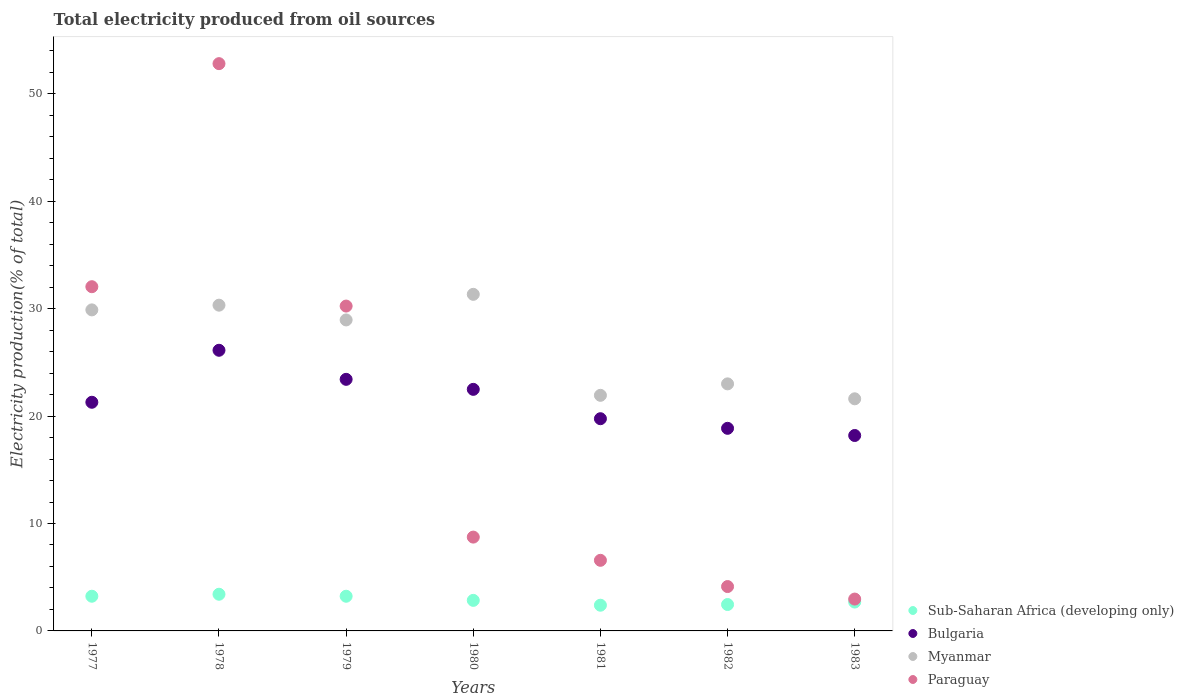How many different coloured dotlines are there?
Offer a terse response. 4. Is the number of dotlines equal to the number of legend labels?
Offer a very short reply. Yes. What is the total electricity produced in Bulgaria in 1980?
Your response must be concise. 22.49. Across all years, what is the maximum total electricity produced in Bulgaria?
Provide a succinct answer. 26.13. Across all years, what is the minimum total electricity produced in Sub-Saharan Africa (developing only)?
Keep it short and to the point. 2.39. In which year was the total electricity produced in Sub-Saharan Africa (developing only) maximum?
Provide a short and direct response. 1978. In which year was the total electricity produced in Bulgaria minimum?
Offer a terse response. 1983. What is the total total electricity produced in Sub-Saharan Africa (developing only) in the graph?
Your response must be concise. 20.26. What is the difference between the total electricity produced in Bulgaria in 1978 and that in 1981?
Offer a very short reply. 6.37. What is the difference between the total electricity produced in Paraguay in 1983 and the total electricity produced in Myanmar in 1977?
Ensure brevity in your answer.  -26.93. What is the average total electricity produced in Sub-Saharan Africa (developing only) per year?
Offer a very short reply. 2.89. In the year 1977, what is the difference between the total electricity produced in Bulgaria and total electricity produced in Myanmar?
Offer a terse response. -8.6. What is the ratio of the total electricity produced in Sub-Saharan Africa (developing only) in 1978 to that in 1981?
Your response must be concise. 1.43. What is the difference between the highest and the second highest total electricity produced in Bulgaria?
Provide a short and direct response. 2.71. What is the difference between the highest and the lowest total electricity produced in Paraguay?
Provide a succinct answer. 49.85. In how many years, is the total electricity produced in Paraguay greater than the average total electricity produced in Paraguay taken over all years?
Provide a succinct answer. 3. Is the sum of the total electricity produced in Sub-Saharan Africa (developing only) in 1978 and 1980 greater than the maximum total electricity produced in Myanmar across all years?
Offer a terse response. No. Is it the case that in every year, the sum of the total electricity produced in Myanmar and total electricity produced in Sub-Saharan Africa (developing only)  is greater than the total electricity produced in Bulgaria?
Give a very brief answer. Yes. Is the total electricity produced in Myanmar strictly greater than the total electricity produced in Paraguay over the years?
Give a very brief answer. No. Is the total electricity produced in Sub-Saharan Africa (developing only) strictly less than the total electricity produced in Myanmar over the years?
Your answer should be compact. Yes. Where does the legend appear in the graph?
Offer a very short reply. Bottom right. How are the legend labels stacked?
Your answer should be very brief. Vertical. What is the title of the graph?
Keep it short and to the point. Total electricity produced from oil sources. Does "Ireland" appear as one of the legend labels in the graph?
Keep it short and to the point. No. What is the label or title of the X-axis?
Ensure brevity in your answer.  Years. What is the Electricity production(% of total) of Sub-Saharan Africa (developing only) in 1977?
Your answer should be compact. 3.23. What is the Electricity production(% of total) of Bulgaria in 1977?
Ensure brevity in your answer.  21.29. What is the Electricity production(% of total) of Myanmar in 1977?
Provide a short and direct response. 29.89. What is the Electricity production(% of total) in Paraguay in 1977?
Your answer should be very brief. 32.05. What is the Electricity production(% of total) in Sub-Saharan Africa (developing only) in 1978?
Your answer should be very brief. 3.41. What is the Electricity production(% of total) in Bulgaria in 1978?
Offer a very short reply. 26.13. What is the Electricity production(% of total) of Myanmar in 1978?
Your answer should be compact. 30.33. What is the Electricity production(% of total) of Paraguay in 1978?
Your answer should be compact. 52.82. What is the Electricity production(% of total) of Sub-Saharan Africa (developing only) in 1979?
Provide a short and direct response. 3.23. What is the Electricity production(% of total) in Bulgaria in 1979?
Provide a succinct answer. 23.42. What is the Electricity production(% of total) in Myanmar in 1979?
Ensure brevity in your answer.  28.96. What is the Electricity production(% of total) of Paraguay in 1979?
Your answer should be compact. 30.25. What is the Electricity production(% of total) in Sub-Saharan Africa (developing only) in 1980?
Provide a succinct answer. 2.84. What is the Electricity production(% of total) of Bulgaria in 1980?
Provide a short and direct response. 22.49. What is the Electricity production(% of total) of Myanmar in 1980?
Your response must be concise. 31.34. What is the Electricity production(% of total) of Paraguay in 1980?
Offer a very short reply. 8.74. What is the Electricity production(% of total) of Sub-Saharan Africa (developing only) in 1981?
Provide a short and direct response. 2.39. What is the Electricity production(% of total) in Bulgaria in 1981?
Provide a short and direct response. 19.76. What is the Electricity production(% of total) of Myanmar in 1981?
Offer a terse response. 21.94. What is the Electricity production(% of total) in Paraguay in 1981?
Keep it short and to the point. 6.57. What is the Electricity production(% of total) of Sub-Saharan Africa (developing only) in 1982?
Your answer should be compact. 2.46. What is the Electricity production(% of total) in Bulgaria in 1982?
Offer a terse response. 18.86. What is the Electricity production(% of total) in Myanmar in 1982?
Make the answer very short. 23. What is the Electricity production(% of total) of Paraguay in 1982?
Offer a very short reply. 4.13. What is the Electricity production(% of total) of Sub-Saharan Africa (developing only) in 1983?
Ensure brevity in your answer.  2.69. What is the Electricity production(% of total) of Bulgaria in 1983?
Offer a very short reply. 18.2. What is the Electricity production(% of total) in Myanmar in 1983?
Give a very brief answer. 21.61. What is the Electricity production(% of total) in Paraguay in 1983?
Give a very brief answer. 2.97. Across all years, what is the maximum Electricity production(% of total) of Sub-Saharan Africa (developing only)?
Ensure brevity in your answer.  3.41. Across all years, what is the maximum Electricity production(% of total) in Bulgaria?
Provide a succinct answer. 26.13. Across all years, what is the maximum Electricity production(% of total) in Myanmar?
Your answer should be very brief. 31.34. Across all years, what is the maximum Electricity production(% of total) of Paraguay?
Give a very brief answer. 52.82. Across all years, what is the minimum Electricity production(% of total) in Sub-Saharan Africa (developing only)?
Your response must be concise. 2.39. Across all years, what is the minimum Electricity production(% of total) of Bulgaria?
Ensure brevity in your answer.  18.2. Across all years, what is the minimum Electricity production(% of total) in Myanmar?
Give a very brief answer. 21.61. Across all years, what is the minimum Electricity production(% of total) of Paraguay?
Keep it short and to the point. 2.97. What is the total Electricity production(% of total) of Sub-Saharan Africa (developing only) in the graph?
Your answer should be compact. 20.26. What is the total Electricity production(% of total) of Bulgaria in the graph?
Give a very brief answer. 150.15. What is the total Electricity production(% of total) in Myanmar in the graph?
Ensure brevity in your answer.  187.06. What is the total Electricity production(% of total) of Paraguay in the graph?
Offer a very short reply. 137.52. What is the difference between the Electricity production(% of total) of Sub-Saharan Africa (developing only) in 1977 and that in 1978?
Offer a very short reply. -0.19. What is the difference between the Electricity production(% of total) of Bulgaria in 1977 and that in 1978?
Keep it short and to the point. -4.84. What is the difference between the Electricity production(% of total) of Myanmar in 1977 and that in 1978?
Keep it short and to the point. -0.44. What is the difference between the Electricity production(% of total) in Paraguay in 1977 and that in 1978?
Provide a succinct answer. -20.77. What is the difference between the Electricity production(% of total) in Sub-Saharan Africa (developing only) in 1977 and that in 1979?
Provide a short and direct response. 0. What is the difference between the Electricity production(% of total) in Bulgaria in 1977 and that in 1979?
Make the answer very short. -2.14. What is the difference between the Electricity production(% of total) of Myanmar in 1977 and that in 1979?
Make the answer very short. 0.94. What is the difference between the Electricity production(% of total) in Paraguay in 1977 and that in 1979?
Make the answer very short. 1.8. What is the difference between the Electricity production(% of total) in Sub-Saharan Africa (developing only) in 1977 and that in 1980?
Offer a very short reply. 0.39. What is the difference between the Electricity production(% of total) of Bulgaria in 1977 and that in 1980?
Give a very brief answer. -1.2. What is the difference between the Electricity production(% of total) of Myanmar in 1977 and that in 1980?
Provide a short and direct response. -1.45. What is the difference between the Electricity production(% of total) in Paraguay in 1977 and that in 1980?
Offer a terse response. 23.31. What is the difference between the Electricity production(% of total) of Sub-Saharan Africa (developing only) in 1977 and that in 1981?
Provide a succinct answer. 0.84. What is the difference between the Electricity production(% of total) of Bulgaria in 1977 and that in 1981?
Ensure brevity in your answer.  1.53. What is the difference between the Electricity production(% of total) of Myanmar in 1977 and that in 1981?
Make the answer very short. 7.96. What is the difference between the Electricity production(% of total) in Paraguay in 1977 and that in 1981?
Make the answer very short. 25.48. What is the difference between the Electricity production(% of total) of Sub-Saharan Africa (developing only) in 1977 and that in 1982?
Provide a short and direct response. 0.77. What is the difference between the Electricity production(% of total) in Bulgaria in 1977 and that in 1982?
Your answer should be compact. 2.43. What is the difference between the Electricity production(% of total) in Myanmar in 1977 and that in 1982?
Offer a terse response. 6.89. What is the difference between the Electricity production(% of total) in Paraguay in 1977 and that in 1982?
Your answer should be very brief. 27.92. What is the difference between the Electricity production(% of total) in Sub-Saharan Africa (developing only) in 1977 and that in 1983?
Your answer should be very brief. 0.54. What is the difference between the Electricity production(% of total) in Bulgaria in 1977 and that in 1983?
Provide a succinct answer. 3.09. What is the difference between the Electricity production(% of total) of Myanmar in 1977 and that in 1983?
Offer a terse response. 8.28. What is the difference between the Electricity production(% of total) of Paraguay in 1977 and that in 1983?
Your response must be concise. 29.08. What is the difference between the Electricity production(% of total) in Sub-Saharan Africa (developing only) in 1978 and that in 1979?
Your answer should be compact. 0.19. What is the difference between the Electricity production(% of total) in Bulgaria in 1978 and that in 1979?
Your response must be concise. 2.71. What is the difference between the Electricity production(% of total) of Myanmar in 1978 and that in 1979?
Give a very brief answer. 1.37. What is the difference between the Electricity production(% of total) of Paraguay in 1978 and that in 1979?
Your answer should be very brief. 22.57. What is the difference between the Electricity production(% of total) in Sub-Saharan Africa (developing only) in 1978 and that in 1980?
Give a very brief answer. 0.57. What is the difference between the Electricity production(% of total) of Bulgaria in 1978 and that in 1980?
Offer a very short reply. 3.64. What is the difference between the Electricity production(% of total) in Myanmar in 1978 and that in 1980?
Offer a terse response. -1.01. What is the difference between the Electricity production(% of total) of Paraguay in 1978 and that in 1980?
Offer a terse response. 44.08. What is the difference between the Electricity production(% of total) in Sub-Saharan Africa (developing only) in 1978 and that in 1981?
Your response must be concise. 1.02. What is the difference between the Electricity production(% of total) in Bulgaria in 1978 and that in 1981?
Keep it short and to the point. 6.37. What is the difference between the Electricity production(% of total) in Myanmar in 1978 and that in 1981?
Your answer should be compact. 8.39. What is the difference between the Electricity production(% of total) in Paraguay in 1978 and that in 1981?
Offer a terse response. 46.24. What is the difference between the Electricity production(% of total) of Sub-Saharan Africa (developing only) in 1978 and that in 1982?
Offer a very short reply. 0.96. What is the difference between the Electricity production(% of total) of Bulgaria in 1978 and that in 1982?
Your answer should be compact. 7.27. What is the difference between the Electricity production(% of total) of Myanmar in 1978 and that in 1982?
Your response must be concise. 7.33. What is the difference between the Electricity production(% of total) in Paraguay in 1978 and that in 1982?
Make the answer very short. 48.69. What is the difference between the Electricity production(% of total) in Sub-Saharan Africa (developing only) in 1978 and that in 1983?
Make the answer very short. 0.73. What is the difference between the Electricity production(% of total) of Bulgaria in 1978 and that in 1983?
Offer a terse response. 7.93. What is the difference between the Electricity production(% of total) in Myanmar in 1978 and that in 1983?
Offer a terse response. 8.72. What is the difference between the Electricity production(% of total) of Paraguay in 1978 and that in 1983?
Your answer should be very brief. 49.85. What is the difference between the Electricity production(% of total) in Sub-Saharan Africa (developing only) in 1979 and that in 1980?
Keep it short and to the point. 0.38. What is the difference between the Electricity production(% of total) in Bulgaria in 1979 and that in 1980?
Make the answer very short. 0.93. What is the difference between the Electricity production(% of total) of Myanmar in 1979 and that in 1980?
Offer a very short reply. -2.38. What is the difference between the Electricity production(% of total) in Paraguay in 1979 and that in 1980?
Your answer should be compact. 21.51. What is the difference between the Electricity production(% of total) of Sub-Saharan Africa (developing only) in 1979 and that in 1981?
Make the answer very short. 0.84. What is the difference between the Electricity production(% of total) in Bulgaria in 1979 and that in 1981?
Provide a short and direct response. 3.67. What is the difference between the Electricity production(% of total) of Myanmar in 1979 and that in 1981?
Offer a terse response. 7.02. What is the difference between the Electricity production(% of total) of Paraguay in 1979 and that in 1981?
Ensure brevity in your answer.  23.67. What is the difference between the Electricity production(% of total) of Sub-Saharan Africa (developing only) in 1979 and that in 1982?
Keep it short and to the point. 0.77. What is the difference between the Electricity production(% of total) of Bulgaria in 1979 and that in 1982?
Offer a terse response. 4.56. What is the difference between the Electricity production(% of total) of Myanmar in 1979 and that in 1982?
Ensure brevity in your answer.  5.95. What is the difference between the Electricity production(% of total) in Paraguay in 1979 and that in 1982?
Your answer should be very brief. 26.11. What is the difference between the Electricity production(% of total) of Sub-Saharan Africa (developing only) in 1979 and that in 1983?
Offer a terse response. 0.54. What is the difference between the Electricity production(% of total) in Bulgaria in 1979 and that in 1983?
Give a very brief answer. 5.23. What is the difference between the Electricity production(% of total) in Myanmar in 1979 and that in 1983?
Your response must be concise. 7.34. What is the difference between the Electricity production(% of total) of Paraguay in 1979 and that in 1983?
Provide a short and direct response. 27.28. What is the difference between the Electricity production(% of total) in Sub-Saharan Africa (developing only) in 1980 and that in 1981?
Keep it short and to the point. 0.45. What is the difference between the Electricity production(% of total) of Bulgaria in 1980 and that in 1981?
Make the answer very short. 2.73. What is the difference between the Electricity production(% of total) of Myanmar in 1980 and that in 1981?
Your answer should be very brief. 9.4. What is the difference between the Electricity production(% of total) in Paraguay in 1980 and that in 1981?
Offer a terse response. 2.16. What is the difference between the Electricity production(% of total) of Sub-Saharan Africa (developing only) in 1980 and that in 1982?
Provide a short and direct response. 0.39. What is the difference between the Electricity production(% of total) in Bulgaria in 1980 and that in 1982?
Keep it short and to the point. 3.63. What is the difference between the Electricity production(% of total) in Myanmar in 1980 and that in 1982?
Provide a succinct answer. 8.34. What is the difference between the Electricity production(% of total) in Paraguay in 1980 and that in 1982?
Provide a succinct answer. 4.6. What is the difference between the Electricity production(% of total) in Sub-Saharan Africa (developing only) in 1980 and that in 1983?
Give a very brief answer. 0.16. What is the difference between the Electricity production(% of total) in Bulgaria in 1980 and that in 1983?
Offer a very short reply. 4.3. What is the difference between the Electricity production(% of total) in Myanmar in 1980 and that in 1983?
Offer a very short reply. 9.73. What is the difference between the Electricity production(% of total) of Paraguay in 1980 and that in 1983?
Make the answer very short. 5.77. What is the difference between the Electricity production(% of total) of Sub-Saharan Africa (developing only) in 1981 and that in 1982?
Your answer should be very brief. -0.06. What is the difference between the Electricity production(% of total) of Bulgaria in 1981 and that in 1982?
Offer a very short reply. 0.89. What is the difference between the Electricity production(% of total) in Myanmar in 1981 and that in 1982?
Keep it short and to the point. -1.07. What is the difference between the Electricity production(% of total) of Paraguay in 1981 and that in 1982?
Give a very brief answer. 2.44. What is the difference between the Electricity production(% of total) of Sub-Saharan Africa (developing only) in 1981 and that in 1983?
Offer a very short reply. -0.29. What is the difference between the Electricity production(% of total) of Bulgaria in 1981 and that in 1983?
Keep it short and to the point. 1.56. What is the difference between the Electricity production(% of total) of Myanmar in 1981 and that in 1983?
Your response must be concise. 0.32. What is the difference between the Electricity production(% of total) of Paraguay in 1981 and that in 1983?
Your response must be concise. 3.61. What is the difference between the Electricity production(% of total) in Sub-Saharan Africa (developing only) in 1982 and that in 1983?
Provide a short and direct response. -0.23. What is the difference between the Electricity production(% of total) in Bulgaria in 1982 and that in 1983?
Provide a succinct answer. 0.67. What is the difference between the Electricity production(% of total) of Myanmar in 1982 and that in 1983?
Ensure brevity in your answer.  1.39. What is the difference between the Electricity production(% of total) of Paraguay in 1982 and that in 1983?
Provide a short and direct response. 1.17. What is the difference between the Electricity production(% of total) in Sub-Saharan Africa (developing only) in 1977 and the Electricity production(% of total) in Bulgaria in 1978?
Your answer should be very brief. -22.9. What is the difference between the Electricity production(% of total) in Sub-Saharan Africa (developing only) in 1977 and the Electricity production(% of total) in Myanmar in 1978?
Provide a succinct answer. -27.1. What is the difference between the Electricity production(% of total) in Sub-Saharan Africa (developing only) in 1977 and the Electricity production(% of total) in Paraguay in 1978?
Provide a short and direct response. -49.59. What is the difference between the Electricity production(% of total) in Bulgaria in 1977 and the Electricity production(% of total) in Myanmar in 1978?
Your answer should be compact. -9.04. What is the difference between the Electricity production(% of total) in Bulgaria in 1977 and the Electricity production(% of total) in Paraguay in 1978?
Give a very brief answer. -31.53. What is the difference between the Electricity production(% of total) in Myanmar in 1977 and the Electricity production(% of total) in Paraguay in 1978?
Your response must be concise. -22.93. What is the difference between the Electricity production(% of total) in Sub-Saharan Africa (developing only) in 1977 and the Electricity production(% of total) in Bulgaria in 1979?
Make the answer very short. -20.19. What is the difference between the Electricity production(% of total) in Sub-Saharan Africa (developing only) in 1977 and the Electricity production(% of total) in Myanmar in 1979?
Give a very brief answer. -25.73. What is the difference between the Electricity production(% of total) of Sub-Saharan Africa (developing only) in 1977 and the Electricity production(% of total) of Paraguay in 1979?
Your response must be concise. -27.02. What is the difference between the Electricity production(% of total) in Bulgaria in 1977 and the Electricity production(% of total) in Myanmar in 1979?
Provide a short and direct response. -7.67. What is the difference between the Electricity production(% of total) in Bulgaria in 1977 and the Electricity production(% of total) in Paraguay in 1979?
Provide a short and direct response. -8.96. What is the difference between the Electricity production(% of total) of Myanmar in 1977 and the Electricity production(% of total) of Paraguay in 1979?
Your response must be concise. -0.36. What is the difference between the Electricity production(% of total) in Sub-Saharan Africa (developing only) in 1977 and the Electricity production(% of total) in Bulgaria in 1980?
Provide a short and direct response. -19.26. What is the difference between the Electricity production(% of total) of Sub-Saharan Africa (developing only) in 1977 and the Electricity production(% of total) of Myanmar in 1980?
Give a very brief answer. -28.11. What is the difference between the Electricity production(% of total) in Sub-Saharan Africa (developing only) in 1977 and the Electricity production(% of total) in Paraguay in 1980?
Provide a succinct answer. -5.51. What is the difference between the Electricity production(% of total) of Bulgaria in 1977 and the Electricity production(% of total) of Myanmar in 1980?
Your answer should be compact. -10.05. What is the difference between the Electricity production(% of total) of Bulgaria in 1977 and the Electricity production(% of total) of Paraguay in 1980?
Offer a terse response. 12.55. What is the difference between the Electricity production(% of total) in Myanmar in 1977 and the Electricity production(% of total) in Paraguay in 1980?
Ensure brevity in your answer.  21.16. What is the difference between the Electricity production(% of total) in Sub-Saharan Africa (developing only) in 1977 and the Electricity production(% of total) in Bulgaria in 1981?
Give a very brief answer. -16.53. What is the difference between the Electricity production(% of total) in Sub-Saharan Africa (developing only) in 1977 and the Electricity production(% of total) in Myanmar in 1981?
Make the answer very short. -18.71. What is the difference between the Electricity production(% of total) of Sub-Saharan Africa (developing only) in 1977 and the Electricity production(% of total) of Paraguay in 1981?
Offer a very short reply. -3.34. What is the difference between the Electricity production(% of total) in Bulgaria in 1977 and the Electricity production(% of total) in Myanmar in 1981?
Make the answer very short. -0.65. What is the difference between the Electricity production(% of total) of Bulgaria in 1977 and the Electricity production(% of total) of Paraguay in 1981?
Give a very brief answer. 14.72. What is the difference between the Electricity production(% of total) of Myanmar in 1977 and the Electricity production(% of total) of Paraguay in 1981?
Keep it short and to the point. 23.32. What is the difference between the Electricity production(% of total) of Sub-Saharan Africa (developing only) in 1977 and the Electricity production(% of total) of Bulgaria in 1982?
Provide a short and direct response. -15.63. What is the difference between the Electricity production(% of total) of Sub-Saharan Africa (developing only) in 1977 and the Electricity production(% of total) of Myanmar in 1982?
Offer a terse response. -19.77. What is the difference between the Electricity production(% of total) in Sub-Saharan Africa (developing only) in 1977 and the Electricity production(% of total) in Paraguay in 1982?
Make the answer very short. -0.9. What is the difference between the Electricity production(% of total) of Bulgaria in 1977 and the Electricity production(% of total) of Myanmar in 1982?
Your answer should be compact. -1.71. What is the difference between the Electricity production(% of total) in Bulgaria in 1977 and the Electricity production(% of total) in Paraguay in 1982?
Ensure brevity in your answer.  17.16. What is the difference between the Electricity production(% of total) in Myanmar in 1977 and the Electricity production(% of total) in Paraguay in 1982?
Your answer should be compact. 25.76. What is the difference between the Electricity production(% of total) of Sub-Saharan Africa (developing only) in 1977 and the Electricity production(% of total) of Bulgaria in 1983?
Offer a very short reply. -14.97. What is the difference between the Electricity production(% of total) in Sub-Saharan Africa (developing only) in 1977 and the Electricity production(% of total) in Myanmar in 1983?
Provide a short and direct response. -18.38. What is the difference between the Electricity production(% of total) in Sub-Saharan Africa (developing only) in 1977 and the Electricity production(% of total) in Paraguay in 1983?
Your response must be concise. 0.26. What is the difference between the Electricity production(% of total) in Bulgaria in 1977 and the Electricity production(% of total) in Myanmar in 1983?
Offer a terse response. -0.32. What is the difference between the Electricity production(% of total) in Bulgaria in 1977 and the Electricity production(% of total) in Paraguay in 1983?
Keep it short and to the point. 18.32. What is the difference between the Electricity production(% of total) of Myanmar in 1977 and the Electricity production(% of total) of Paraguay in 1983?
Offer a terse response. 26.93. What is the difference between the Electricity production(% of total) of Sub-Saharan Africa (developing only) in 1978 and the Electricity production(% of total) of Bulgaria in 1979?
Provide a succinct answer. -20.01. What is the difference between the Electricity production(% of total) of Sub-Saharan Africa (developing only) in 1978 and the Electricity production(% of total) of Myanmar in 1979?
Make the answer very short. -25.54. What is the difference between the Electricity production(% of total) of Sub-Saharan Africa (developing only) in 1978 and the Electricity production(% of total) of Paraguay in 1979?
Keep it short and to the point. -26.83. What is the difference between the Electricity production(% of total) of Bulgaria in 1978 and the Electricity production(% of total) of Myanmar in 1979?
Give a very brief answer. -2.82. What is the difference between the Electricity production(% of total) of Bulgaria in 1978 and the Electricity production(% of total) of Paraguay in 1979?
Provide a short and direct response. -4.12. What is the difference between the Electricity production(% of total) in Myanmar in 1978 and the Electricity production(% of total) in Paraguay in 1979?
Make the answer very short. 0.08. What is the difference between the Electricity production(% of total) of Sub-Saharan Africa (developing only) in 1978 and the Electricity production(% of total) of Bulgaria in 1980?
Offer a terse response. -19.08. What is the difference between the Electricity production(% of total) of Sub-Saharan Africa (developing only) in 1978 and the Electricity production(% of total) of Myanmar in 1980?
Provide a succinct answer. -27.92. What is the difference between the Electricity production(% of total) of Sub-Saharan Africa (developing only) in 1978 and the Electricity production(% of total) of Paraguay in 1980?
Provide a succinct answer. -5.32. What is the difference between the Electricity production(% of total) in Bulgaria in 1978 and the Electricity production(% of total) in Myanmar in 1980?
Ensure brevity in your answer.  -5.21. What is the difference between the Electricity production(% of total) in Bulgaria in 1978 and the Electricity production(% of total) in Paraguay in 1980?
Make the answer very short. 17.4. What is the difference between the Electricity production(% of total) in Myanmar in 1978 and the Electricity production(% of total) in Paraguay in 1980?
Keep it short and to the point. 21.59. What is the difference between the Electricity production(% of total) in Sub-Saharan Africa (developing only) in 1978 and the Electricity production(% of total) in Bulgaria in 1981?
Keep it short and to the point. -16.34. What is the difference between the Electricity production(% of total) in Sub-Saharan Africa (developing only) in 1978 and the Electricity production(% of total) in Myanmar in 1981?
Your response must be concise. -18.52. What is the difference between the Electricity production(% of total) in Sub-Saharan Africa (developing only) in 1978 and the Electricity production(% of total) in Paraguay in 1981?
Keep it short and to the point. -3.16. What is the difference between the Electricity production(% of total) of Bulgaria in 1978 and the Electricity production(% of total) of Myanmar in 1981?
Give a very brief answer. 4.2. What is the difference between the Electricity production(% of total) of Bulgaria in 1978 and the Electricity production(% of total) of Paraguay in 1981?
Keep it short and to the point. 19.56. What is the difference between the Electricity production(% of total) of Myanmar in 1978 and the Electricity production(% of total) of Paraguay in 1981?
Ensure brevity in your answer.  23.76. What is the difference between the Electricity production(% of total) in Sub-Saharan Africa (developing only) in 1978 and the Electricity production(% of total) in Bulgaria in 1982?
Your response must be concise. -15.45. What is the difference between the Electricity production(% of total) in Sub-Saharan Africa (developing only) in 1978 and the Electricity production(% of total) in Myanmar in 1982?
Offer a very short reply. -19.59. What is the difference between the Electricity production(% of total) of Sub-Saharan Africa (developing only) in 1978 and the Electricity production(% of total) of Paraguay in 1982?
Offer a very short reply. -0.72. What is the difference between the Electricity production(% of total) of Bulgaria in 1978 and the Electricity production(% of total) of Myanmar in 1982?
Give a very brief answer. 3.13. What is the difference between the Electricity production(% of total) of Bulgaria in 1978 and the Electricity production(% of total) of Paraguay in 1982?
Offer a very short reply. 22. What is the difference between the Electricity production(% of total) of Myanmar in 1978 and the Electricity production(% of total) of Paraguay in 1982?
Make the answer very short. 26.2. What is the difference between the Electricity production(% of total) of Sub-Saharan Africa (developing only) in 1978 and the Electricity production(% of total) of Bulgaria in 1983?
Provide a succinct answer. -14.78. What is the difference between the Electricity production(% of total) of Sub-Saharan Africa (developing only) in 1978 and the Electricity production(% of total) of Myanmar in 1983?
Ensure brevity in your answer.  -18.2. What is the difference between the Electricity production(% of total) in Sub-Saharan Africa (developing only) in 1978 and the Electricity production(% of total) in Paraguay in 1983?
Keep it short and to the point. 0.45. What is the difference between the Electricity production(% of total) in Bulgaria in 1978 and the Electricity production(% of total) in Myanmar in 1983?
Offer a very short reply. 4.52. What is the difference between the Electricity production(% of total) in Bulgaria in 1978 and the Electricity production(% of total) in Paraguay in 1983?
Give a very brief answer. 23.16. What is the difference between the Electricity production(% of total) of Myanmar in 1978 and the Electricity production(% of total) of Paraguay in 1983?
Provide a short and direct response. 27.36. What is the difference between the Electricity production(% of total) of Sub-Saharan Africa (developing only) in 1979 and the Electricity production(% of total) of Bulgaria in 1980?
Provide a succinct answer. -19.26. What is the difference between the Electricity production(% of total) in Sub-Saharan Africa (developing only) in 1979 and the Electricity production(% of total) in Myanmar in 1980?
Give a very brief answer. -28.11. What is the difference between the Electricity production(% of total) of Sub-Saharan Africa (developing only) in 1979 and the Electricity production(% of total) of Paraguay in 1980?
Offer a terse response. -5.51. What is the difference between the Electricity production(% of total) of Bulgaria in 1979 and the Electricity production(% of total) of Myanmar in 1980?
Offer a very short reply. -7.91. What is the difference between the Electricity production(% of total) in Bulgaria in 1979 and the Electricity production(% of total) in Paraguay in 1980?
Ensure brevity in your answer.  14.69. What is the difference between the Electricity production(% of total) of Myanmar in 1979 and the Electricity production(% of total) of Paraguay in 1980?
Offer a very short reply. 20.22. What is the difference between the Electricity production(% of total) in Sub-Saharan Africa (developing only) in 1979 and the Electricity production(% of total) in Bulgaria in 1981?
Make the answer very short. -16.53. What is the difference between the Electricity production(% of total) of Sub-Saharan Africa (developing only) in 1979 and the Electricity production(% of total) of Myanmar in 1981?
Make the answer very short. -18.71. What is the difference between the Electricity production(% of total) of Sub-Saharan Africa (developing only) in 1979 and the Electricity production(% of total) of Paraguay in 1981?
Your answer should be very brief. -3.34. What is the difference between the Electricity production(% of total) in Bulgaria in 1979 and the Electricity production(% of total) in Myanmar in 1981?
Ensure brevity in your answer.  1.49. What is the difference between the Electricity production(% of total) in Bulgaria in 1979 and the Electricity production(% of total) in Paraguay in 1981?
Your answer should be compact. 16.85. What is the difference between the Electricity production(% of total) of Myanmar in 1979 and the Electricity production(% of total) of Paraguay in 1981?
Keep it short and to the point. 22.38. What is the difference between the Electricity production(% of total) in Sub-Saharan Africa (developing only) in 1979 and the Electricity production(% of total) in Bulgaria in 1982?
Offer a very short reply. -15.63. What is the difference between the Electricity production(% of total) of Sub-Saharan Africa (developing only) in 1979 and the Electricity production(% of total) of Myanmar in 1982?
Provide a succinct answer. -19.77. What is the difference between the Electricity production(% of total) in Sub-Saharan Africa (developing only) in 1979 and the Electricity production(% of total) in Paraguay in 1982?
Provide a short and direct response. -0.9. What is the difference between the Electricity production(% of total) in Bulgaria in 1979 and the Electricity production(% of total) in Myanmar in 1982?
Give a very brief answer. 0.42. What is the difference between the Electricity production(% of total) in Bulgaria in 1979 and the Electricity production(% of total) in Paraguay in 1982?
Your answer should be very brief. 19.29. What is the difference between the Electricity production(% of total) of Myanmar in 1979 and the Electricity production(% of total) of Paraguay in 1982?
Offer a very short reply. 24.82. What is the difference between the Electricity production(% of total) of Sub-Saharan Africa (developing only) in 1979 and the Electricity production(% of total) of Bulgaria in 1983?
Ensure brevity in your answer.  -14.97. What is the difference between the Electricity production(% of total) in Sub-Saharan Africa (developing only) in 1979 and the Electricity production(% of total) in Myanmar in 1983?
Ensure brevity in your answer.  -18.38. What is the difference between the Electricity production(% of total) in Sub-Saharan Africa (developing only) in 1979 and the Electricity production(% of total) in Paraguay in 1983?
Keep it short and to the point. 0.26. What is the difference between the Electricity production(% of total) of Bulgaria in 1979 and the Electricity production(% of total) of Myanmar in 1983?
Keep it short and to the point. 1.81. What is the difference between the Electricity production(% of total) in Bulgaria in 1979 and the Electricity production(% of total) in Paraguay in 1983?
Ensure brevity in your answer.  20.46. What is the difference between the Electricity production(% of total) in Myanmar in 1979 and the Electricity production(% of total) in Paraguay in 1983?
Offer a terse response. 25.99. What is the difference between the Electricity production(% of total) of Sub-Saharan Africa (developing only) in 1980 and the Electricity production(% of total) of Bulgaria in 1981?
Keep it short and to the point. -16.91. What is the difference between the Electricity production(% of total) of Sub-Saharan Africa (developing only) in 1980 and the Electricity production(% of total) of Myanmar in 1981?
Your answer should be very brief. -19.09. What is the difference between the Electricity production(% of total) in Sub-Saharan Africa (developing only) in 1980 and the Electricity production(% of total) in Paraguay in 1981?
Give a very brief answer. -3.73. What is the difference between the Electricity production(% of total) in Bulgaria in 1980 and the Electricity production(% of total) in Myanmar in 1981?
Offer a terse response. 0.56. What is the difference between the Electricity production(% of total) in Bulgaria in 1980 and the Electricity production(% of total) in Paraguay in 1981?
Your answer should be compact. 15.92. What is the difference between the Electricity production(% of total) of Myanmar in 1980 and the Electricity production(% of total) of Paraguay in 1981?
Provide a short and direct response. 24.76. What is the difference between the Electricity production(% of total) in Sub-Saharan Africa (developing only) in 1980 and the Electricity production(% of total) in Bulgaria in 1982?
Provide a short and direct response. -16.02. What is the difference between the Electricity production(% of total) in Sub-Saharan Africa (developing only) in 1980 and the Electricity production(% of total) in Myanmar in 1982?
Provide a short and direct response. -20.16. What is the difference between the Electricity production(% of total) in Sub-Saharan Africa (developing only) in 1980 and the Electricity production(% of total) in Paraguay in 1982?
Your response must be concise. -1.29. What is the difference between the Electricity production(% of total) of Bulgaria in 1980 and the Electricity production(% of total) of Myanmar in 1982?
Give a very brief answer. -0.51. What is the difference between the Electricity production(% of total) of Bulgaria in 1980 and the Electricity production(% of total) of Paraguay in 1982?
Provide a short and direct response. 18.36. What is the difference between the Electricity production(% of total) in Myanmar in 1980 and the Electricity production(% of total) in Paraguay in 1982?
Your answer should be very brief. 27.21. What is the difference between the Electricity production(% of total) of Sub-Saharan Africa (developing only) in 1980 and the Electricity production(% of total) of Bulgaria in 1983?
Make the answer very short. -15.35. What is the difference between the Electricity production(% of total) in Sub-Saharan Africa (developing only) in 1980 and the Electricity production(% of total) in Myanmar in 1983?
Provide a succinct answer. -18.77. What is the difference between the Electricity production(% of total) of Sub-Saharan Africa (developing only) in 1980 and the Electricity production(% of total) of Paraguay in 1983?
Your answer should be very brief. -0.12. What is the difference between the Electricity production(% of total) in Bulgaria in 1980 and the Electricity production(% of total) in Myanmar in 1983?
Keep it short and to the point. 0.88. What is the difference between the Electricity production(% of total) in Bulgaria in 1980 and the Electricity production(% of total) in Paraguay in 1983?
Ensure brevity in your answer.  19.53. What is the difference between the Electricity production(% of total) of Myanmar in 1980 and the Electricity production(% of total) of Paraguay in 1983?
Your response must be concise. 28.37. What is the difference between the Electricity production(% of total) of Sub-Saharan Africa (developing only) in 1981 and the Electricity production(% of total) of Bulgaria in 1982?
Offer a terse response. -16.47. What is the difference between the Electricity production(% of total) of Sub-Saharan Africa (developing only) in 1981 and the Electricity production(% of total) of Myanmar in 1982?
Offer a terse response. -20.61. What is the difference between the Electricity production(% of total) of Sub-Saharan Africa (developing only) in 1981 and the Electricity production(% of total) of Paraguay in 1982?
Ensure brevity in your answer.  -1.74. What is the difference between the Electricity production(% of total) of Bulgaria in 1981 and the Electricity production(% of total) of Myanmar in 1982?
Keep it short and to the point. -3.24. What is the difference between the Electricity production(% of total) of Bulgaria in 1981 and the Electricity production(% of total) of Paraguay in 1982?
Provide a succinct answer. 15.63. What is the difference between the Electricity production(% of total) in Myanmar in 1981 and the Electricity production(% of total) in Paraguay in 1982?
Provide a short and direct response. 17.8. What is the difference between the Electricity production(% of total) of Sub-Saharan Africa (developing only) in 1981 and the Electricity production(% of total) of Bulgaria in 1983?
Your answer should be very brief. -15.8. What is the difference between the Electricity production(% of total) in Sub-Saharan Africa (developing only) in 1981 and the Electricity production(% of total) in Myanmar in 1983?
Make the answer very short. -19.22. What is the difference between the Electricity production(% of total) of Sub-Saharan Africa (developing only) in 1981 and the Electricity production(% of total) of Paraguay in 1983?
Your answer should be very brief. -0.57. What is the difference between the Electricity production(% of total) of Bulgaria in 1981 and the Electricity production(% of total) of Myanmar in 1983?
Your response must be concise. -1.85. What is the difference between the Electricity production(% of total) in Bulgaria in 1981 and the Electricity production(% of total) in Paraguay in 1983?
Ensure brevity in your answer.  16.79. What is the difference between the Electricity production(% of total) of Myanmar in 1981 and the Electricity production(% of total) of Paraguay in 1983?
Keep it short and to the point. 18.97. What is the difference between the Electricity production(% of total) in Sub-Saharan Africa (developing only) in 1982 and the Electricity production(% of total) in Bulgaria in 1983?
Provide a short and direct response. -15.74. What is the difference between the Electricity production(% of total) in Sub-Saharan Africa (developing only) in 1982 and the Electricity production(% of total) in Myanmar in 1983?
Provide a succinct answer. -19.15. What is the difference between the Electricity production(% of total) of Sub-Saharan Africa (developing only) in 1982 and the Electricity production(% of total) of Paraguay in 1983?
Ensure brevity in your answer.  -0.51. What is the difference between the Electricity production(% of total) in Bulgaria in 1982 and the Electricity production(% of total) in Myanmar in 1983?
Your response must be concise. -2.75. What is the difference between the Electricity production(% of total) of Bulgaria in 1982 and the Electricity production(% of total) of Paraguay in 1983?
Offer a terse response. 15.9. What is the difference between the Electricity production(% of total) in Myanmar in 1982 and the Electricity production(% of total) in Paraguay in 1983?
Provide a succinct answer. 20.04. What is the average Electricity production(% of total) of Sub-Saharan Africa (developing only) per year?
Keep it short and to the point. 2.89. What is the average Electricity production(% of total) of Bulgaria per year?
Give a very brief answer. 21.45. What is the average Electricity production(% of total) of Myanmar per year?
Keep it short and to the point. 26.72. What is the average Electricity production(% of total) of Paraguay per year?
Offer a terse response. 19.65. In the year 1977, what is the difference between the Electricity production(% of total) of Sub-Saharan Africa (developing only) and Electricity production(% of total) of Bulgaria?
Your answer should be very brief. -18.06. In the year 1977, what is the difference between the Electricity production(% of total) in Sub-Saharan Africa (developing only) and Electricity production(% of total) in Myanmar?
Your response must be concise. -26.66. In the year 1977, what is the difference between the Electricity production(% of total) of Sub-Saharan Africa (developing only) and Electricity production(% of total) of Paraguay?
Keep it short and to the point. -28.82. In the year 1977, what is the difference between the Electricity production(% of total) of Bulgaria and Electricity production(% of total) of Myanmar?
Keep it short and to the point. -8.6. In the year 1977, what is the difference between the Electricity production(% of total) in Bulgaria and Electricity production(% of total) in Paraguay?
Your answer should be very brief. -10.76. In the year 1977, what is the difference between the Electricity production(% of total) in Myanmar and Electricity production(% of total) in Paraguay?
Make the answer very short. -2.16. In the year 1978, what is the difference between the Electricity production(% of total) of Sub-Saharan Africa (developing only) and Electricity production(% of total) of Bulgaria?
Make the answer very short. -22.72. In the year 1978, what is the difference between the Electricity production(% of total) of Sub-Saharan Africa (developing only) and Electricity production(% of total) of Myanmar?
Your answer should be compact. -26.92. In the year 1978, what is the difference between the Electricity production(% of total) in Sub-Saharan Africa (developing only) and Electricity production(% of total) in Paraguay?
Your response must be concise. -49.4. In the year 1978, what is the difference between the Electricity production(% of total) in Bulgaria and Electricity production(% of total) in Myanmar?
Offer a very short reply. -4.2. In the year 1978, what is the difference between the Electricity production(% of total) of Bulgaria and Electricity production(% of total) of Paraguay?
Keep it short and to the point. -26.69. In the year 1978, what is the difference between the Electricity production(% of total) of Myanmar and Electricity production(% of total) of Paraguay?
Provide a succinct answer. -22.49. In the year 1979, what is the difference between the Electricity production(% of total) in Sub-Saharan Africa (developing only) and Electricity production(% of total) in Bulgaria?
Give a very brief answer. -20.2. In the year 1979, what is the difference between the Electricity production(% of total) of Sub-Saharan Africa (developing only) and Electricity production(% of total) of Myanmar?
Offer a terse response. -25.73. In the year 1979, what is the difference between the Electricity production(% of total) of Sub-Saharan Africa (developing only) and Electricity production(% of total) of Paraguay?
Offer a terse response. -27.02. In the year 1979, what is the difference between the Electricity production(% of total) of Bulgaria and Electricity production(% of total) of Myanmar?
Ensure brevity in your answer.  -5.53. In the year 1979, what is the difference between the Electricity production(% of total) in Bulgaria and Electricity production(% of total) in Paraguay?
Give a very brief answer. -6.82. In the year 1979, what is the difference between the Electricity production(% of total) in Myanmar and Electricity production(% of total) in Paraguay?
Your answer should be very brief. -1.29. In the year 1980, what is the difference between the Electricity production(% of total) in Sub-Saharan Africa (developing only) and Electricity production(% of total) in Bulgaria?
Your answer should be very brief. -19.65. In the year 1980, what is the difference between the Electricity production(% of total) of Sub-Saharan Africa (developing only) and Electricity production(% of total) of Myanmar?
Ensure brevity in your answer.  -28.49. In the year 1980, what is the difference between the Electricity production(% of total) of Sub-Saharan Africa (developing only) and Electricity production(% of total) of Paraguay?
Offer a terse response. -5.89. In the year 1980, what is the difference between the Electricity production(% of total) in Bulgaria and Electricity production(% of total) in Myanmar?
Provide a succinct answer. -8.85. In the year 1980, what is the difference between the Electricity production(% of total) in Bulgaria and Electricity production(% of total) in Paraguay?
Your response must be concise. 13.76. In the year 1980, what is the difference between the Electricity production(% of total) in Myanmar and Electricity production(% of total) in Paraguay?
Make the answer very short. 22.6. In the year 1981, what is the difference between the Electricity production(% of total) of Sub-Saharan Africa (developing only) and Electricity production(% of total) of Bulgaria?
Give a very brief answer. -17.36. In the year 1981, what is the difference between the Electricity production(% of total) of Sub-Saharan Africa (developing only) and Electricity production(% of total) of Myanmar?
Keep it short and to the point. -19.54. In the year 1981, what is the difference between the Electricity production(% of total) of Sub-Saharan Africa (developing only) and Electricity production(% of total) of Paraguay?
Provide a succinct answer. -4.18. In the year 1981, what is the difference between the Electricity production(% of total) in Bulgaria and Electricity production(% of total) in Myanmar?
Your response must be concise. -2.18. In the year 1981, what is the difference between the Electricity production(% of total) in Bulgaria and Electricity production(% of total) in Paraguay?
Offer a very short reply. 13.18. In the year 1981, what is the difference between the Electricity production(% of total) in Myanmar and Electricity production(% of total) in Paraguay?
Give a very brief answer. 15.36. In the year 1982, what is the difference between the Electricity production(% of total) in Sub-Saharan Africa (developing only) and Electricity production(% of total) in Bulgaria?
Provide a short and direct response. -16.41. In the year 1982, what is the difference between the Electricity production(% of total) in Sub-Saharan Africa (developing only) and Electricity production(% of total) in Myanmar?
Provide a short and direct response. -20.54. In the year 1982, what is the difference between the Electricity production(% of total) in Sub-Saharan Africa (developing only) and Electricity production(% of total) in Paraguay?
Your answer should be compact. -1.67. In the year 1982, what is the difference between the Electricity production(% of total) of Bulgaria and Electricity production(% of total) of Myanmar?
Offer a very short reply. -4.14. In the year 1982, what is the difference between the Electricity production(% of total) in Bulgaria and Electricity production(% of total) in Paraguay?
Your answer should be very brief. 14.73. In the year 1982, what is the difference between the Electricity production(% of total) in Myanmar and Electricity production(% of total) in Paraguay?
Your answer should be compact. 18.87. In the year 1983, what is the difference between the Electricity production(% of total) in Sub-Saharan Africa (developing only) and Electricity production(% of total) in Bulgaria?
Your answer should be very brief. -15.51. In the year 1983, what is the difference between the Electricity production(% of total) of Sub-Saharan Africa (developing only) and Electricity production(% of total) of Myanmar?
Offer a terse response. -18.92. In the year 1983, what is the difference between the Electricity production(% of total) in Sub-Saharan Africa (developing only) and Electricity production(% of total) in Paraguay?
Your response must be concise. -0.28. In the year 1983, what is the difference between the Electricity production(% of total) of Bulgaria and Electricity production(% of total) of Myanmar?
Your answer should be very brief. -3.42. In the year 1983, what is the difference between the Electricity production(% of total) of Bulgaria and Electricity production(% of total) of Paraguay?
Keep it short and to the point. 15.23. In the year 1983, what is the difference between the Electricity production(% of total) of Myanmar and Electricity production(% of total) of Paraguay?
Your response must be concise. 18.65. What is the ratio of the Electricity production(% of total) in Sub-Saharan Africa (developing only) in 1977 to that in 1978?
Provide a short and direct response. 0.95. What is the ratio of the Electricity production(% of total) in Bulgaria in 1977 to that in 1978?
Ensure brevity in your answer.  0.81. What is the ratio of the Electricity production(% of total) of Myanmar in 1977 to that in 1978?
Keep it short and to the point. 0.99. What is the ratio of the Electricity production(% of total) of Paraguay in 1977 to that in 1978?
Provide a short and direct response. 0.61. What is the ratio of the Electricity production(% of total) in Bulgaria in 1977 to that in 1979?
Your answer should be very brief. 0.91. What is the ratio of the Electricity production(% of total) in Myanmar in 1977 to that in 1979?
Keep it short and to the point. 1.03. What is the ratio of the Electricity production(% of total) in Paraguay in 1977 to that in 1979?
Make the answer very short. 1.06. What is the ratio of the Electricity production(% of total) in Sub-Saharan Africa (developing only) in 1977 to that in 1980?
Offer a terse response. 1.14. What is the ratio of the Electricity production(% of total) in Bulgaria in 1977 to that in 1980?
Give a very brief answer. 0.95. What is the ratio of the Electricity production(% of total) of Myanmar in 1977 to that in 1980?
Keep it short and to the point. 0.95. What is the ratio of the Electricity production(% of total) in Paraguay in 1977 to that in 1980?
Make the answer very short. 3.67. What is the ratio of the Electricity production(% of total) in Sub-Saharan Africa (developing only) in 1977 to that in 1981?
Offer a very short reply. 1.35. What is the ratio of the Electricity production(% of total) of Bulgaria in 1977 to that in 1981?
Your answer should be very brief. 1.08. What is the ratio of the Electricity production(% of total) in Myanmar in 1977 to that in 1981?
Ensure brevity in your answer.  1.36. What is the ratio of the Electricity production(% of total) of Paraguay in 1977 to that in 1981?
Make the answer very short. 4.88. What is the ratio of the Electricity production(% of total) in Sub-Saharan Africa (developing only) in 1977 to that in 1982?
Your answer should be very brief. 1.31. What is the ratio of the Electricity production(% of total) in Bulgaria in 1977 to that in 1982?
Your answer should be compact. 1.13. What is the ratio of the Electricity production(% of total) in Myanmar in 1977 to that in 1982?
Provide a short and direct response. 1.3. What is the ratio of the Electricity production(% of total) of Paraguay in 1977 to that in 1982?
Your answer should be very brief. 7.76. What is the ratio of the Electricity production(% of total) in Sub-Saharan Africa (developing only) in 1977 to that in 1983?
Ensure brevity in your answer.  1.2. What is the ratio of the Electricity production(% of total) in Bulgaria in 1977 to that in 1983?
Your answer should be compact. 1.17. What is the ratio of the Electricity production(% of total) in Myanmar in 1977 to that in 1983?
Ensure brevity in your answer.  1.38. What is the ratio of the Electricity production(% of total) of Paraguay in 1977 to that in 1983?
Your response must be concise. 10.81. What is the ratio of the Electricity production(% of total) of Sub-Saharan Africa (developing only) in 1978 to that in 1979?
Your answer should be compact. 1.06. What is the ratio of the Electricity production(% of total) in Bulgaria in 1978 to that in 1979?
Provide a succinct answer. 1.12. What is the ratio of the Electricity production(% of total) in Myanmar in 1978 to that in 1979?
Provide a short and direct response. 1.05. What is the ratio of the Electricity production(% of total) in Paraguay in 1978 to that in 1979?
Offer a very short reply. 1.75. What is the ratio of the Electricity production(% of total) in Sub-Saharan Africa (developing only) in 1978 to that in 1980?
Offer a terse response. 1.2. What is the ratio of the Electricity production(% of total) in Bulgaria in 1978 to that in 1980?
Provide a short and direct response. 1.16. What is the ratio of the Electricity production(% of total) of Myanmar in 1978 to that in 1980?
Offer a terse response. 0.97. What is the ratio of the Electricity production(% of total) of Paraguay in 1978 to that in 1980?
Your answer should be compact. 6.05. What is the ratio of the Electricity production(% of total) in Sub-Saharan Africa (developing only) in 1978 to that in 1981?
Your response must be concise. 1.43. What is the ratio of the Electricity production(% of total) of Bulgaria in 1978 to that in 1981?
Offer a very short reply. 1.32. What is the ratio of the Electricity production(% of total) of Myanmar in 1978 to that in 1981?
Give a very brief answer. 1.38. What is the ratio of the Electricity production(% of total) of Paraguay in 1978 to that in 1981?
Provide a succinct answer. 8.03. What is the ratio of the Electricity production(% of total) in Sub-Saharan Africa (developing only) in 1978 to that in 1982?
Your answer should be compact. 1.39. What is the ratio of the Electricity production(% of total) of Bulgaria in 1978 to that in 1982?
Your answer should be compact. 1.39. What is the ratio of the Electricity production(% of total) of Myanmar in 1978 to that in 1982?
Ensure brevity in your answer.  1.32. What is the ratio of the Electricity production(% of total) of Paraguay in 1978 to that in 1982?
Your response must be concise. 12.79. What is the ratio of the Electricity production(% of total) of Sub-Saharan Africa (developing only) in 1978 to that in 1983?
Give a very brief answer. 1.27. What is the ratio of the Electricity production(% of total) in Bulgaria in 1978 to that in 1983?
Provide a short and direct response. 1.44. What is the ratio of the Electricity production(% of total) of Myanmar in 1978 to that in 1983?
Make the answer very short. 1.4. What is the ratio of the Electricity production(% of total) in Paraguay in 1978 to that in 1983?
Provide a succinct answer. 17.81. What is the ratio of the Electricity production(% of total) in Sub-Saharan Africa (developing only) in 1979 to that in 1980?
Ensure brevity in your answer.  1.14. What is the ratio of the Electricity production(% of total) in Bulgaria in 1979 to that in 1980?
Keep it short and to the point. 1.04. What is the ratio of the Electricity production(% of total) in Myanmar in 1979 to that in 1980?
Offer a very short reply. 0.92. What is the ratio of the Electricity production(% of total) of Paraguay in 1979 to that in 1980?
Your answer should be very brief. 3.46. What is the ratio of the Electricity production(% of total) in Sub-Saharan Africa (developing only) in 1979 to that in 1981?
Offer a very short reply. 1.35. What is the ratio of the Electricity production(% of total) of Bulgaria in 1979 to that in 1981?
Keep it short and to the point. 1.19. What is the ratio of the Electricity production(% of total) of Myanmar in 1979 to that in 1981?
Provide a short and direct response. 1.32. What is the ratio of the Electricity production(% of total) in Paraguay in 1979 to that in 1981?
Provide a short and direct response. 4.6. What is the ratio of the Electricity production(% of total) of Sub-Saharan Africa (developing only) in 1979 to that in 1982?
Make the answer very short. 1.31. What is the ratio of the Electricity production(% of total) in Bulgaria in 1979 to that in 1982?
Provide a short and direct response. 1.24. What is the ratio of the Electricity production(% of total) of Myanmar in 1979 to that in 1982?
Ensure brevity in your answer.  1.26. What is the ratio of the Electricity production(% of total) of Paraguay in 1979 to that in 1982?
Offer a terse response. 7.32. What is the ratio of the Electricity production(% of total) of Sub-Saharan Africa (developing only) in 1979 to that in 1983?
Offer a very short reply. 1.2. What is the ratio of the Electricity production(% of total) of Bulgaria in 1979 to that in 1983?
Your answer should be compact. 1.29. What is the ratio of the Electricity production(% of total) of Myanmar in 1979 to that in 1983?
Your response must be concise. 1.34. What is the ratio of the Electricity production(% of total) of Paraguay in 1979 to that in 1983?
Make the answer very short. 10.2. What is the ratio of the Electricity production(% of total) in Sub-Saharan Africa (developing only) in 1980 to that in 1981?
Keep it short and to the point. 1.19. What is the ratio of the Electricity production(% of total) of Bulgaria in 1980 to that in 1981?
Ensure brevity in your answer.  1.14. What is the ratio of the Electricity production(% of total) of Myanmar in 1980 to that in 1981?
Offer a terse response. 1.43. What is the ratio of the Electricity production(% of total) of Paraguay in 1980 to that in 1981?
Make the answer very short. 1.33. What is the ratio of the Electricity production(% of total) in Sub-Saharan Africa (developing only) in 1980 to that in 1982?
Ensure brevity in your answer.  1.16. What is the ratio of the Electricity production(% of total) in Bulgaria in 1980 to that in 1982?
Offer a terse response. 1.19. What is the ratio of the Electricity production(% of total) in Myanmar in 1980 to that in 1982?
Your answer should be compact. 1.36. What is the ratio of the Electricity production(% of total) of Paraguay in 1980 to that in 1982?
Your response must be concise. 2.11. What is the ratio of the Electricity production(% of total) of Sub-Saharan Africa (developing only) in 1980 to that in 1983?
Your response must be concise. 1.06. What is the ratio of the Electricity production(% of total) in Bulgaria in 1980 to that in 1983?
Ensure brevity in your answer.  1.24. What is the ratio of the Electricity production(% of total) in Myanmar in 1980 to that in 1983?
Give a very brief answer. 1.45. What is the ratio of the Electricity production(% of total) in Paraguay in 1980 to that in 1983?
Keep it short and to the point. 2.95. What is the ratio of the Electricity production(% of total) in Sub-Saharan Africa (developing only) in 1981 to that in 1982?
Keep it short and to the point. 0.97. What is the ratio of the Electricity production(% of total) of Bulgaria in 1981 to that in 1982?
Provide a succinct answer. 1.05. What is the ratio of the Electricity production(% of total) in Myanmar in 1981 to that in 1982?
Your response must be concise. 0.95. What is the ratio of the Electricity production(% of total) of Paraguay in 1981 to that in 1982?
Your response must be concise. 1.59. What is the ratio of the Electricity production(% of total) in Sub-Saharan Africa (developing only) in 1981 to that in 1983?
Your response must be concise. 0.89. What is the ratio of the Electricity production(% of total) in Bulgaria in 1981 to that in 1983?
Keep it short and to the point. 1.09. What is the ratio of the Electricity production(% of total) of Myanmar in 1981 to that in 1983?
Offer a terse response. 1.01. What is the ratio of the Electricity production(% of total) in Paraguay in 1981 to that in 1983?
Provide a succinct answer. 2.22. What is the ratio of the Electricity production(% of total) of Sub-Saharan Africa (developing only) in 1982 to that in 1983?
Ensure brevity in your answer.  0.91. What is the ratio of the Electricity production(% of total) of Bulgaria in 1982 to that in 1983?
Keep it short and to the point. 1.04. What is the ratio of the Electricity production(% of total) in Myanmar in 1982 to that in 1983?
Give a very brief answer. 1.06. What is the ratio of the Electricity production(% of total) of Paraguay in 1982 to that in 1983?
Your response must be concise. 1.39. What is the difference between the highest and the second highest Electricity production(% of total) in Sub-Saharan Africa (developing only)?
Give a very brief answer. 0.19. What is the difference between the highest and the second highest Electricity production(% of total) in Bulgaria?
Your answer should be compact. 2.71. What is the difference between the highest and the second highest Electricity production(% of total) of Myanmar?
Offer a very short reply. 1.01. What is the difference between the highest and the second highest Electricity production(% of total) of Paraguay?
Give a very brief answer. 20.77. What is the difference between the highest and the lowest Electricity production(% of total) of Sub-Saharan Africa (developing only)?
Make the answer very short. 1.02. What is the difference between the highest and the lowest Electricity production(% of total) in Bulgaria?
Offer a terse response. 7.93. What is the difference between the highest and the lowest Electricity production(% of total) in Myanmar?
Your answer should be very brief. 9.73. What is the difference between the highest and the lowest Electricity production(% of total) of Paraguay?
Offer a very short reply. 49.85. 